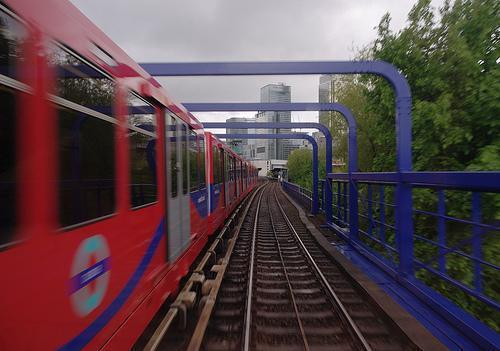How many tracks are there?
Give a very brief answer. 2. How many doors do you see on the train?
Give a very brief answer. 1. 